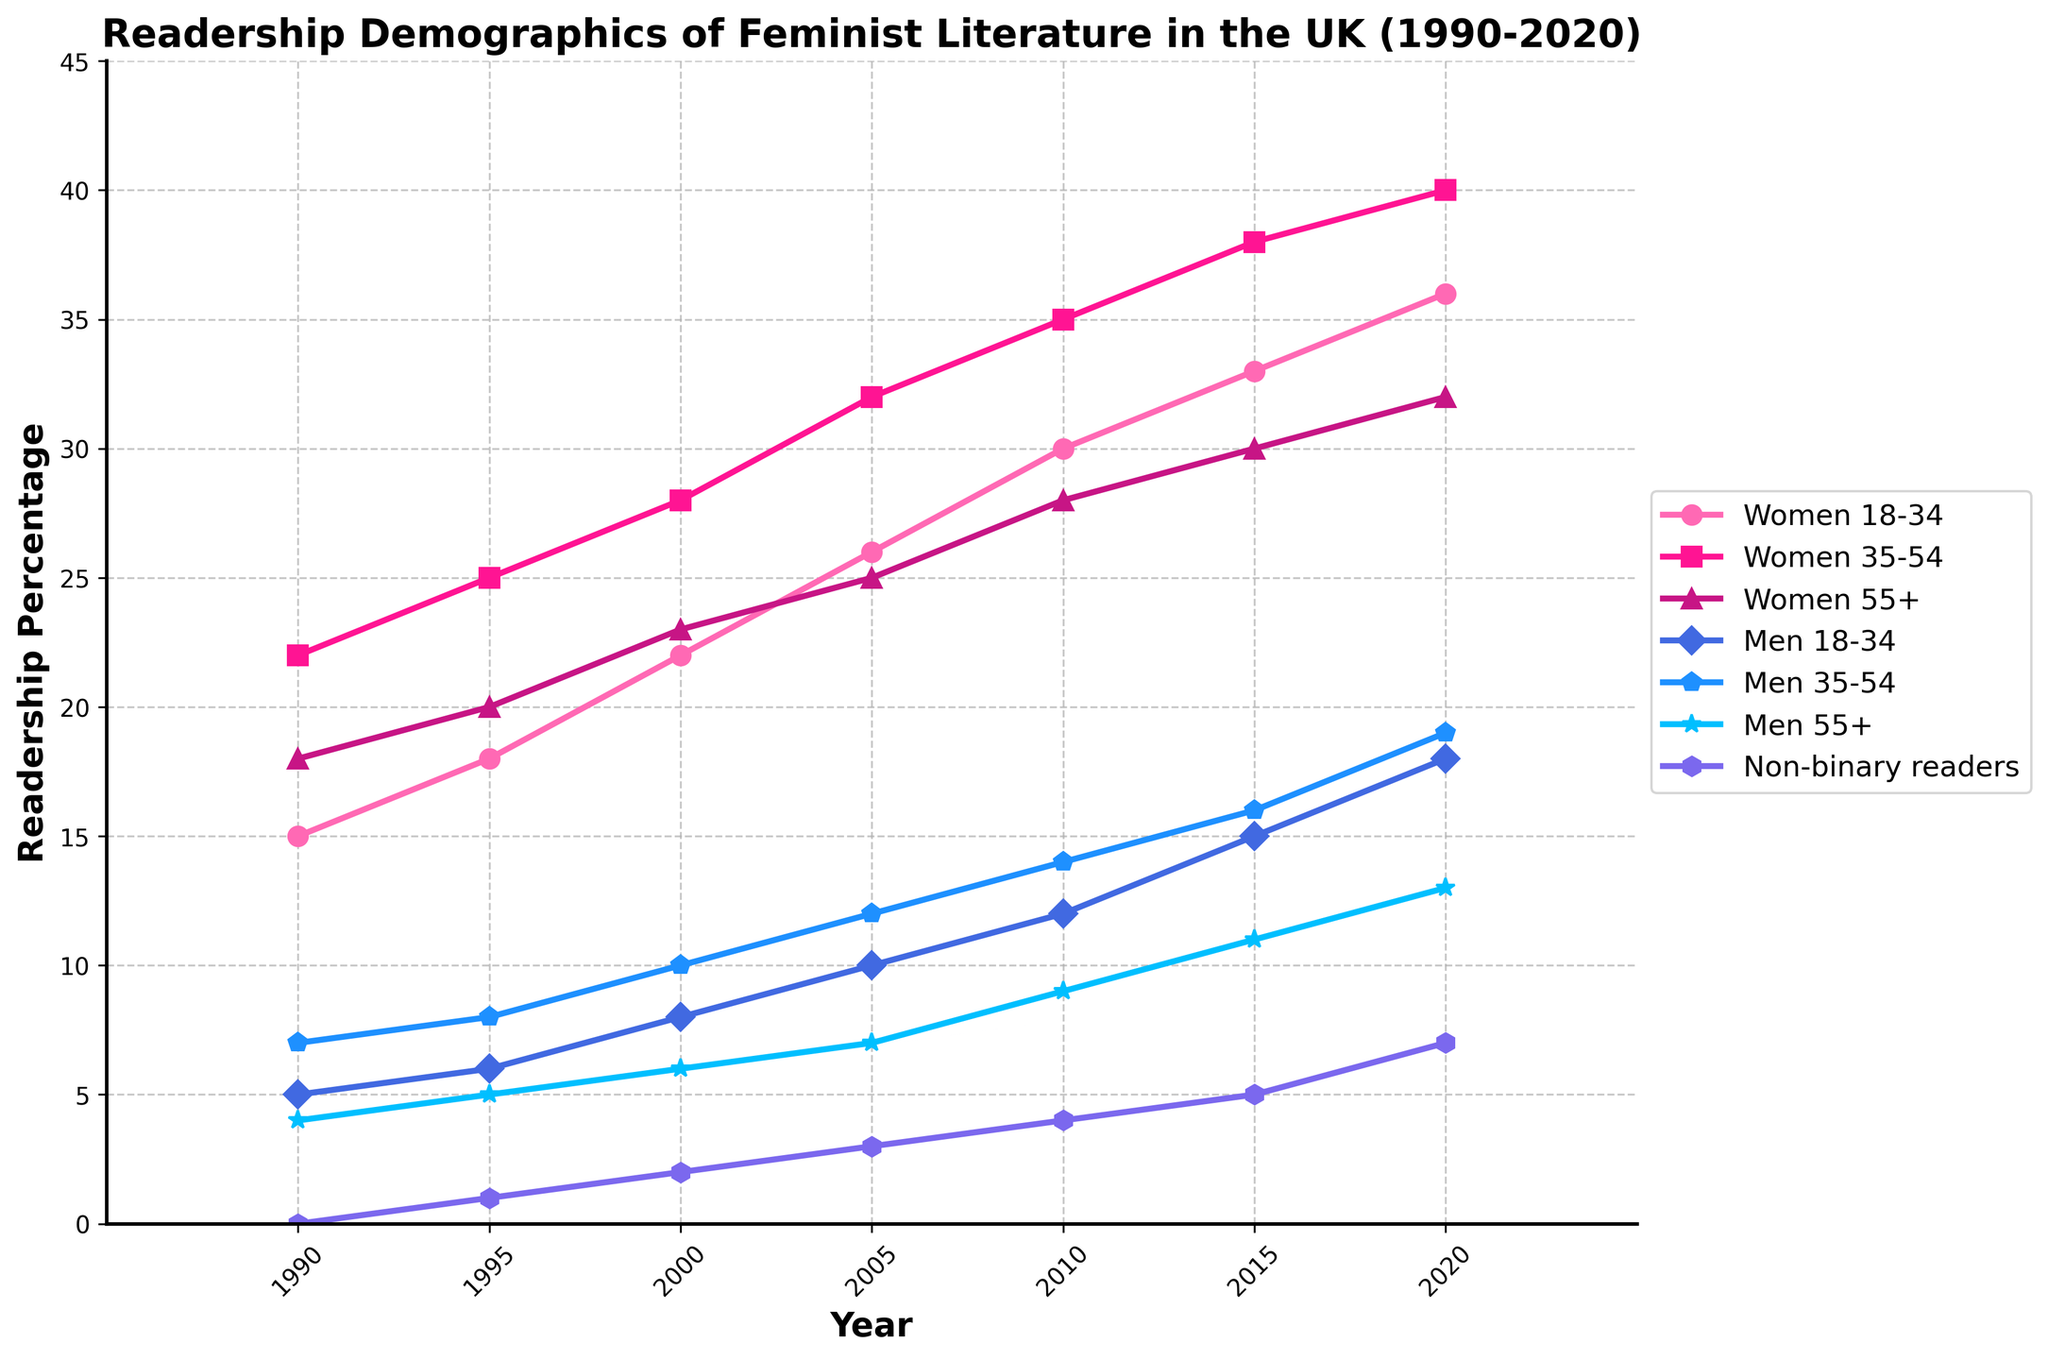How has the readership percentage of Women 18-34 changed from 1990 to 2020? The readership percentage of Women 18-34 in 1990 was 15%. By 2020, it had increased to 36%. The change can be calculated by subtracting the 1990 percentage from the 2020 percentage: 36% - 15% = 21%.
Answer: 21% Which demographic group had the highest readership percentage in 2020? Referring to the end of the plot, we can see that Women 35-54 had the highest readership percentage in 2020, reaching 40%.
Answer: Women 35-54 During which period did Non-binary readers show the largest growth percentage in the readership of feminist literature? To determine this, we need to look at the growth between each period. The Non-binary readership was initially 0% in 1990 and increased to 7% by 2020. By pinpointing the increments: 
- 1990-1995: 0 to 1% (1%) 
- 1995-2000: 1 to 2% (1%) 
- 2000-2005: 2 to 3% (1%) 
- 2005-2010: 3 to 4% (1%) 
- 2010-2015: 4 to 5% (1%) 
- 2015-2020: 5 to 7% (2%) 
The largest growth percentage occurred between 2015 and 2020, at 2%.
Answer: 2015-2020 What is the percentage difference in readership between Men 18-34 and Men 55+ in 2010? In 2010, the readership percentage for Men 18-34 was 12%, and for Men 55+ it was 9%. The percentage difference can be calculated as: 12% - 9% = 3%.
Answer: 3% Which demographic group saw the smallest increase in its readership percentage from 1995 to 2015? By calculating the increase for each group:
- Women 18-34: 33% - 18% = 15%
- Women 35-54: 38% - 25% = 13%
- Women 55+: 30% - 20% = 10%
- Men 18-34: 15% - 6% = 9%
- Men 35-54: 16% - 8% = 8%
- Men 55+: 11% - 5% = 6%
- Non-binary readers: 5% - 1% = 4%
The smallest increase was for Non-binary readers, with an increase of 4%.
Answer: Non-binary readers What is the average readership percentage of Men 35-54 from 1990 to 2020? To find the average, sum the percentages from each year and divide by the number of years. The percentages are 7%, 8%, 10%, 12%, 14%, 16%, and 19%. 
Sum: 7 + 8 + 10 + 12 + 14 + 16 + 19 = 86. 
The number of years is 7. 
Average= 86 / 7  12.29%.
Answer: 12.29% Which two demographic groups had the closest readership percentages in 2005, and what were those percentages? The percentages in 2005 were: 
- Women 18-34: 26%
- Women 35-54: 32%
- Women 55+: 25%
- Men 18-34: 10%
- Men 35-54: 12%
- Men 55+: 7%
- Non-binary readers: 3%
After comparison, the closest percentages were for Women 55+ (25%) and Women 18-34 (26%), with only a 1% difference.
Answer: Women 55+ (25%) and Women 18-34 (26%) In 2020, what was the combined readership percentage of Men 18-34 and Men 35-54? Sum the readership percentages of Men 18-34 and Men 35-54 for 2020. Men 18-34: 18%, Men 35-54: 19%. 
Combined percentage = 18% + 19% = 37%.
Answer: 37% 